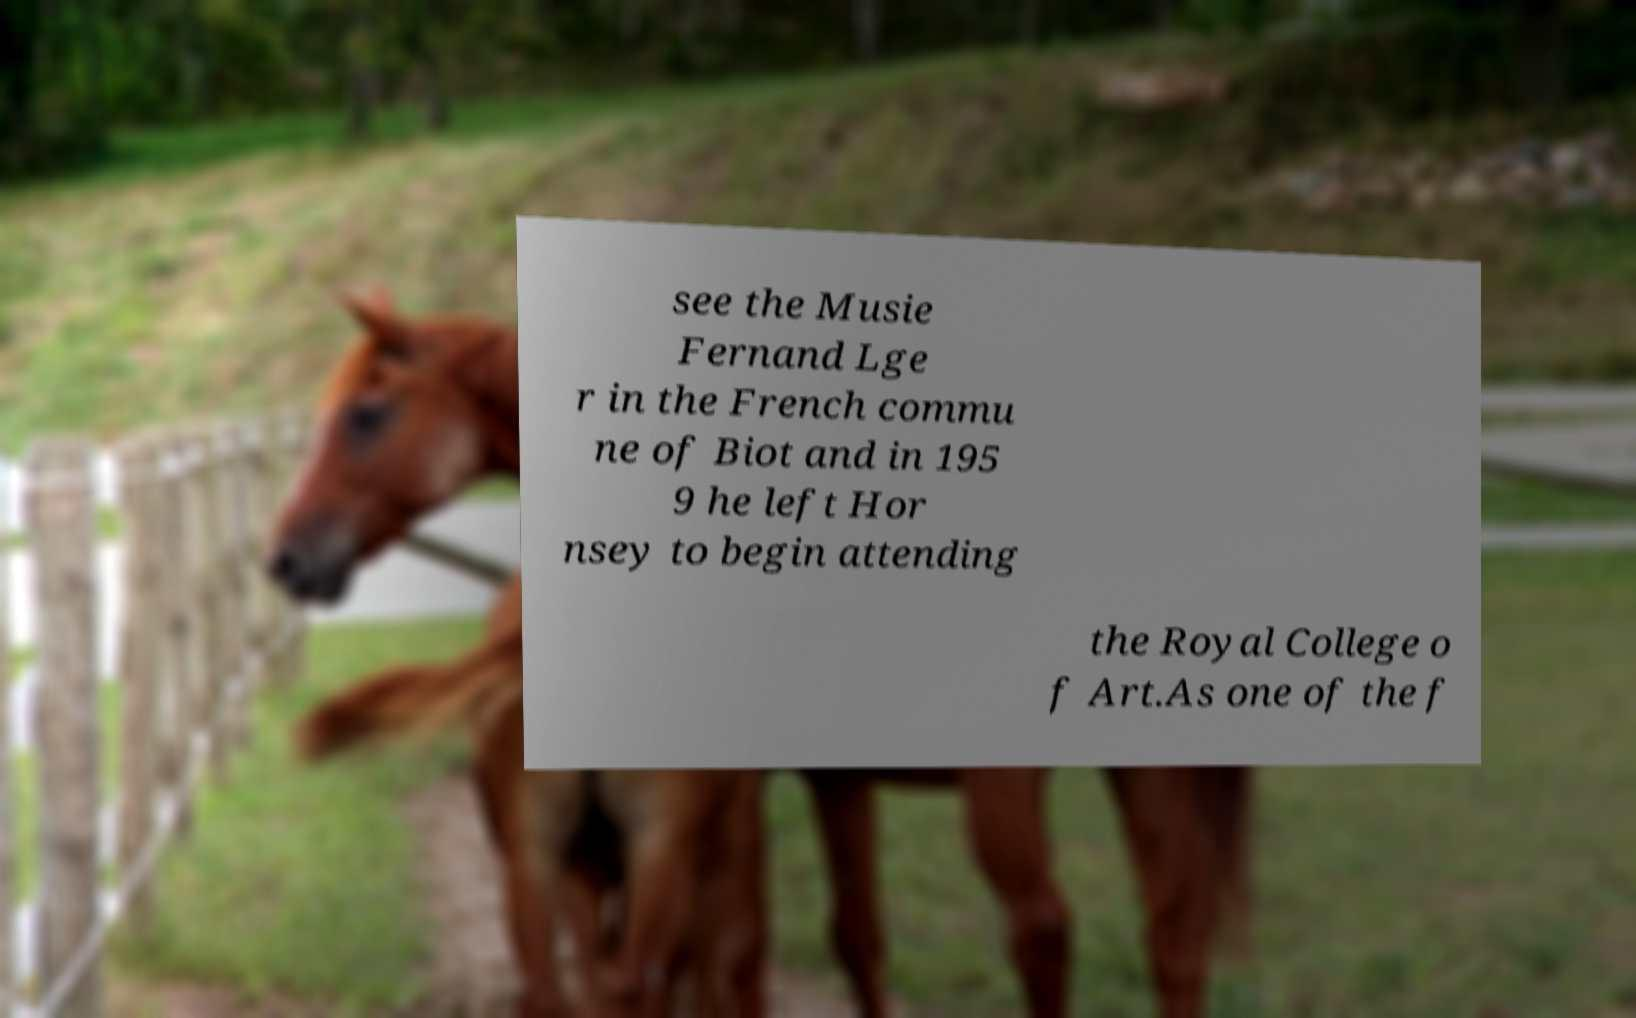I need the written content from this picture converted into text. Can you do that? see the Musie Fernand Lge r in the French commu ne of Biot and in 195 9 he left Hor nsey to begin attending the Royal College o f Art.As one of the f 